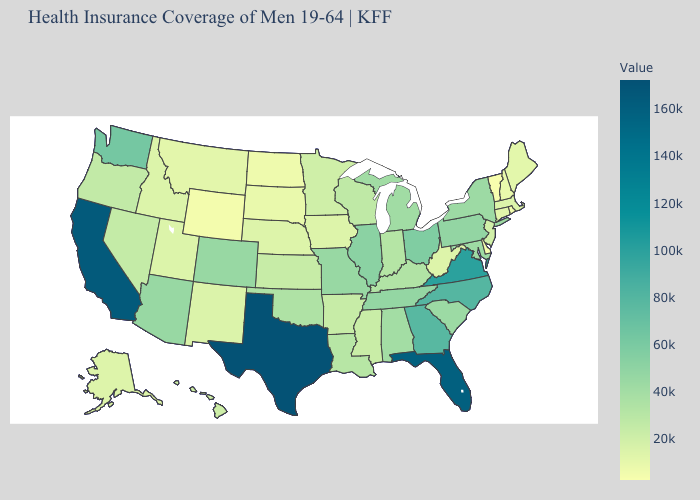Among the states that border North Carolina , which have the highest value?
Quick response, please. Virginia. 